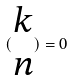Convert formula to latex. <formula><loc_0><loc_0><loc_500><loc_500>( \begin{matrix} k \\ n \end{matrix} ) = 0</formula> 